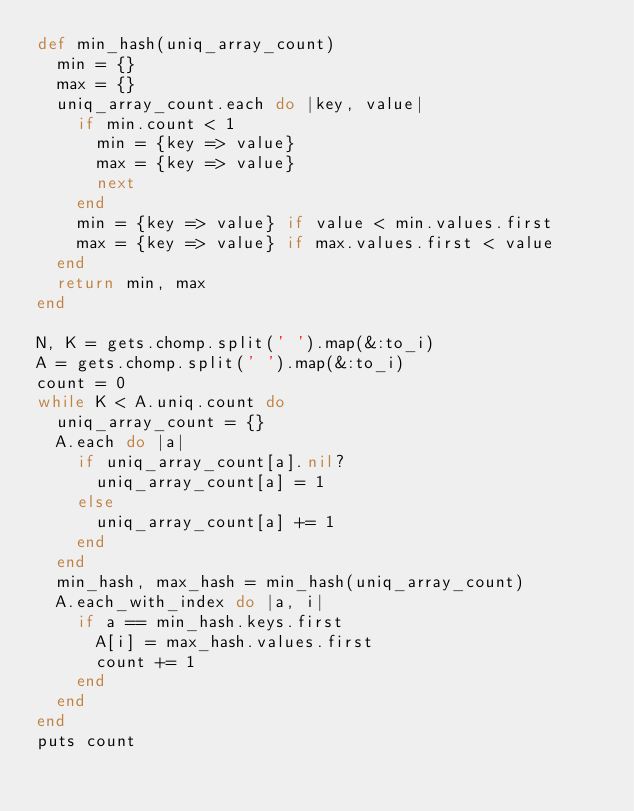<code> <loc_0><loc_0><loc_500><loc_500><_Ruby_>def min_hash(uniq_array_count)
  min = {}
  max = {}
  uniq_array_count.each do |key, value|
    if min.count < 1
      min = {key => value}
      max = {key => value}
      next
    end
    min = {key => value} if value < min.values.first
    max = {key => value} if max.values.first < value
  end
  return min, max
end

N, K = gets.chomp.split(' ').map(&:to_i)
A = gets.chomp.split(' ').map(&:to_i)
count = 0
while K < A.uniq.count do
  uniq_array_count = {}
  A.each do |a|
    if uniq_array_count[a].nil?
      uniq_array_count[a] = 1
    else
      uniq_array_count[a] += 1
    end
  end
  min_hash, max_hash = min_hash(uniq_array_count)
  A.each_with_index do |a, i|
    if a == min_hash.keys.first
      A[i] = max_hash.values.first
      count += 1
    end
  end
end
puts count</code> 